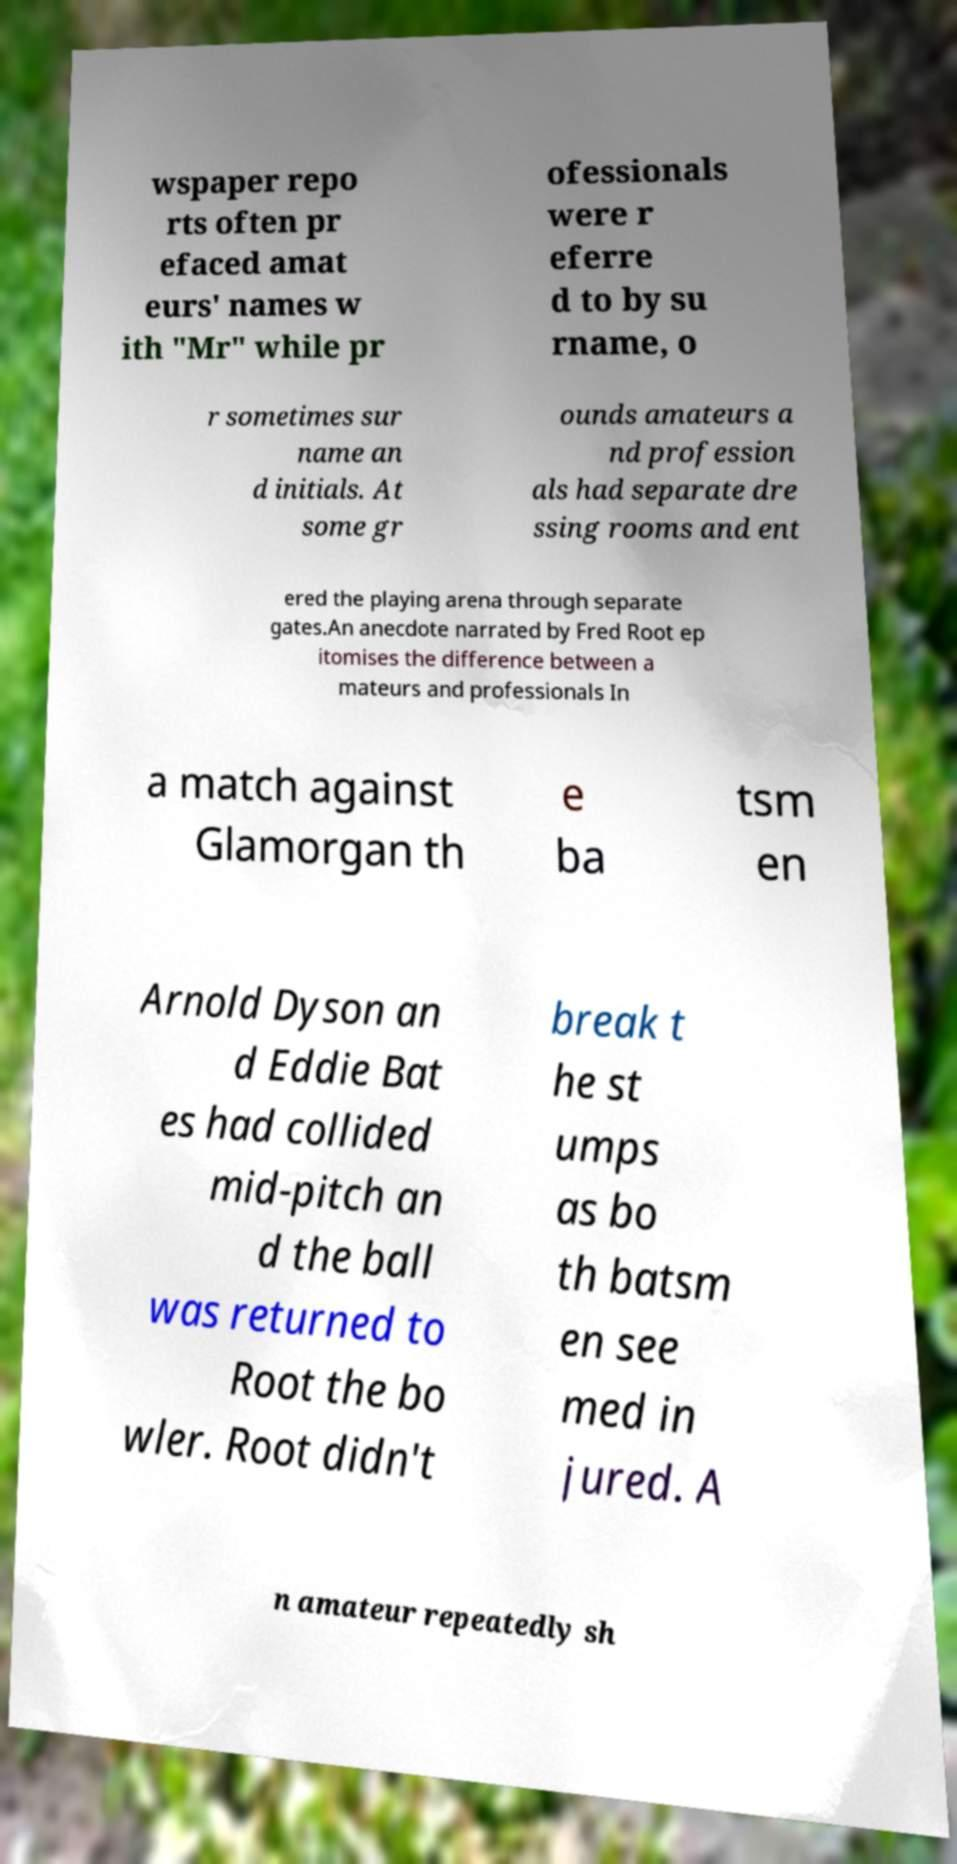What messages or text are displayed in this image? I need them in a readable, typed format. wspaper repo rts often pr efaced amat eurs' names w ith "Mr" while pr ofessionals were r eferre d to by su rname, o r sometimes sur name an d initials. At some gr ounds amateurs a nd profession als had separate dre ssing rooms and ent ered the playing arena through separate gates.An anecdote narrated by Fred Root ep itomises the difference between a mateurs and professionals In a match against Glamorgan th e ba tsm en Arnold Dyson an d Eddie Bat es had collided mid-pitch an d the ball was returned to Root the bo wler. Root didn't break t he st umps as bo th batsm en see med in jured. A n amateur repeatedly sh 